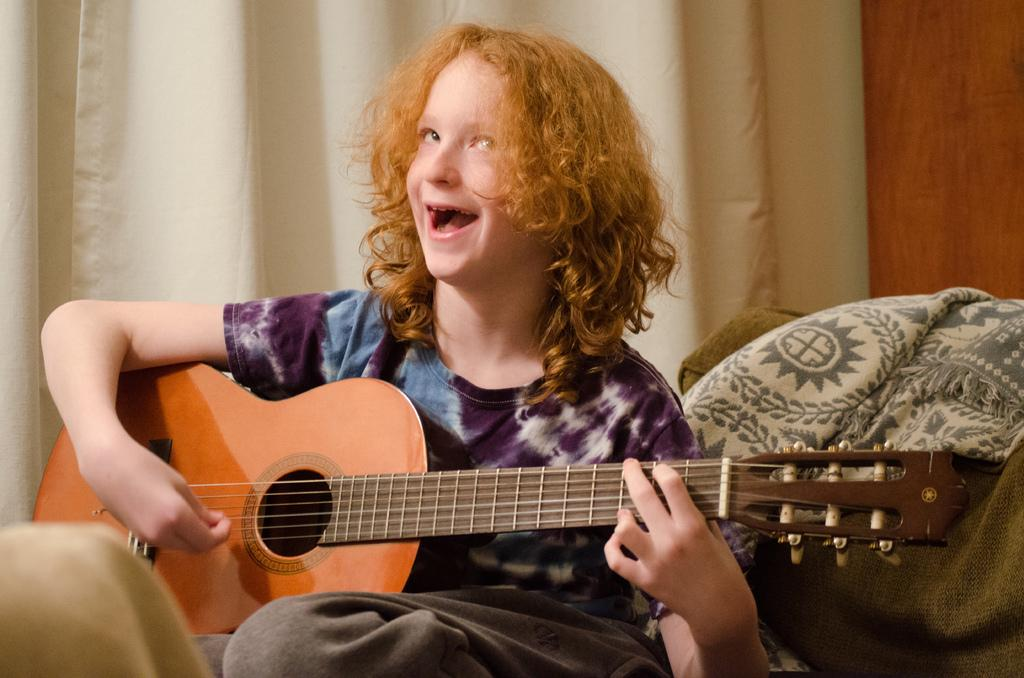Who is the main subject in the image? There is a girl in the image. What is the girl doing in the image? The girl is sitting in the image. What object is the girl holding in her hand? The girl is holding a guitar in her hand. What type of texture can be seen on the wine bottle in the image? There is no wine bottle present in the image. The girl is holding a guitar, not a wine bottle. 